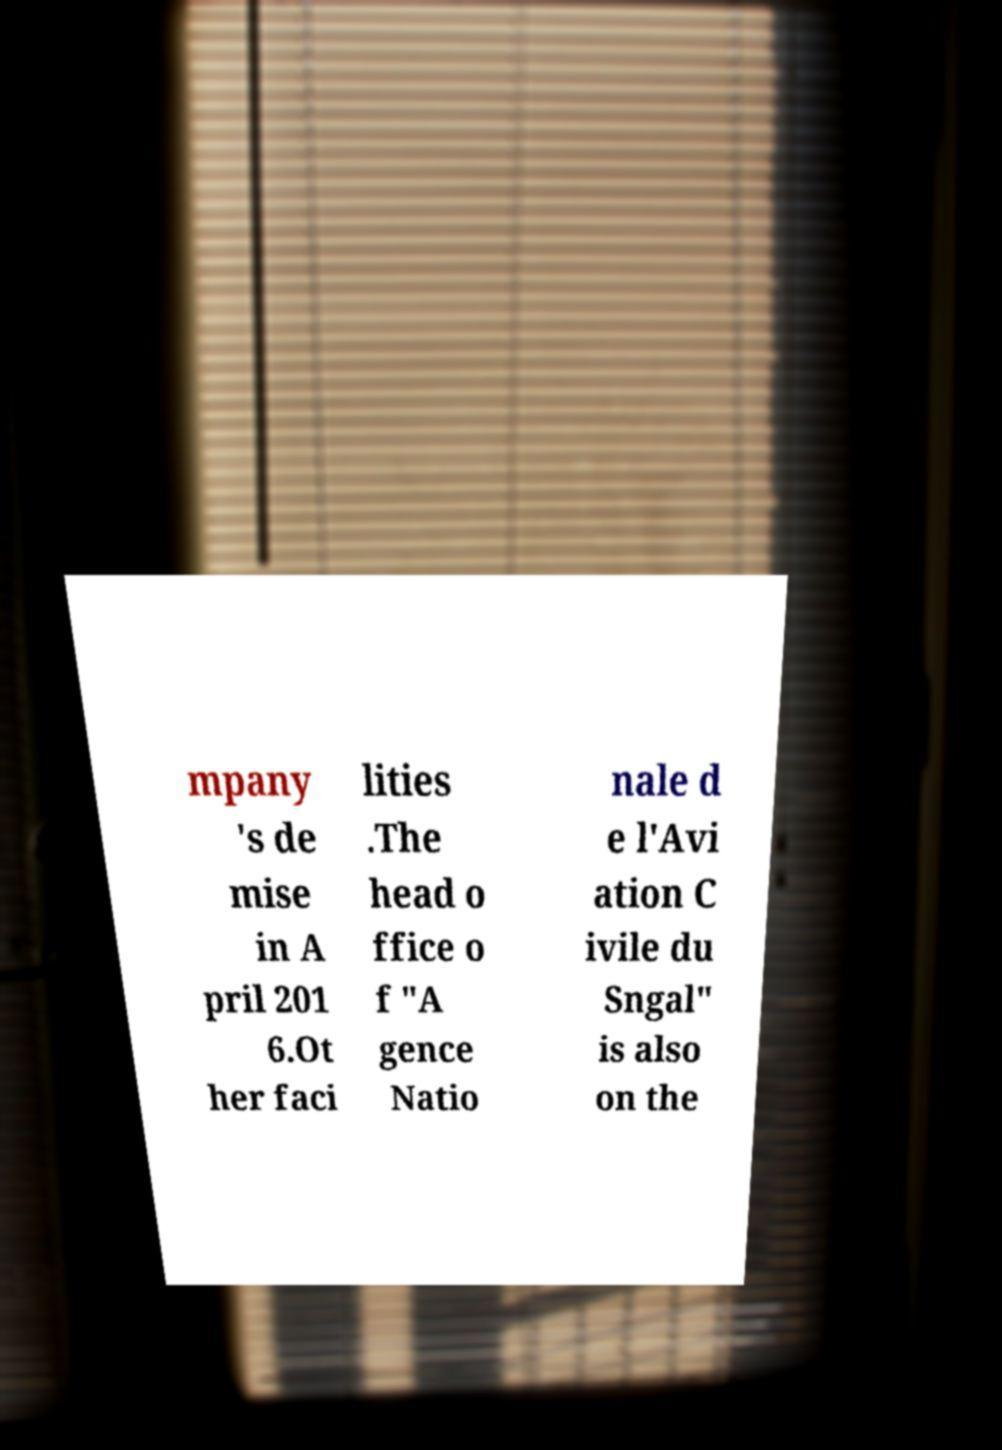Can you accurately transcribe the text from the provided image for me? mpany 's de mise in A pril 201 6.Ot her faci lities .The head o ffice o f "A gence Natio nale d e l'Avi ation C ivile du Sngal" is also on the 